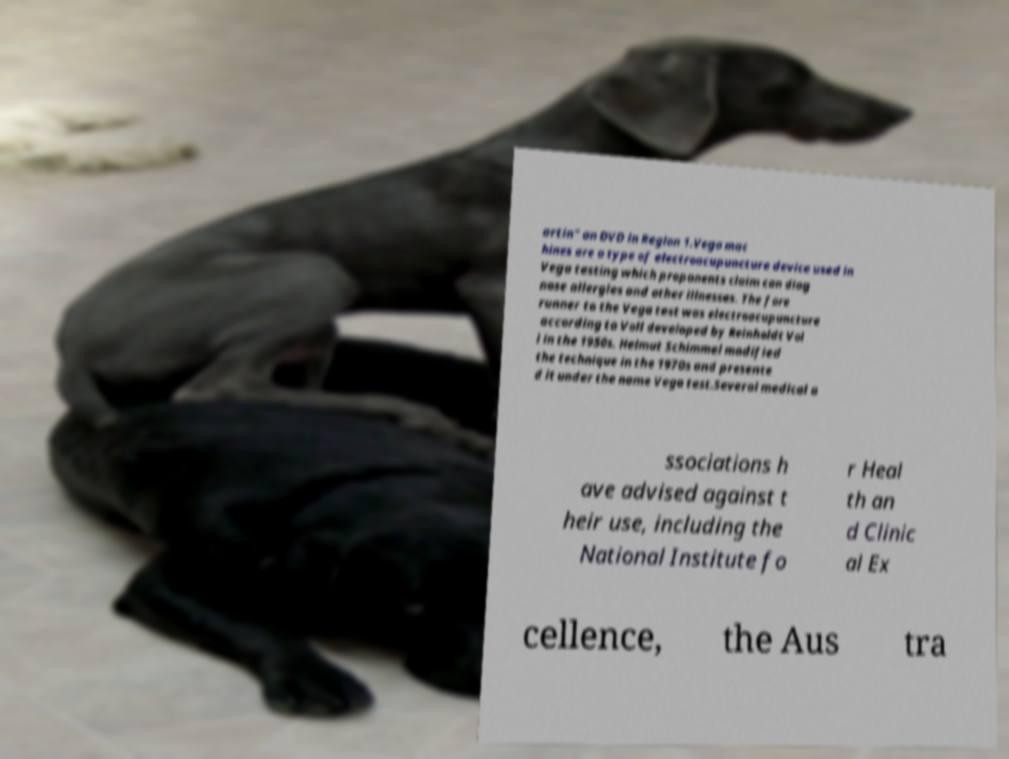For documentation purposes, I need the text within this image transcribed. Could you provide that? artin" on DVD in Region 1.Vega mac hines are a type of electroacupuncture device used in Vega testing which proponents claim can diag nose allergies and other illnesses. The fore runner to the Vega test was electroacupuncture according to Voll developed by Reinholdt Vol l in the 1950s. Helmut Schimmel modified the technique in the 1970s and presente d it under the name Vega test.Several medical a ssociations h ave advised against t heir use, including the National Institute fo r Heal th an d Clinic al Ex cellence, the Aus tra 